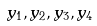<formula> <loc_0><loc_0><loc_500><loc_500>y _ { 1 } , y _ { 2 } , y _ { 3 } , y _ { 4 }</formula> 